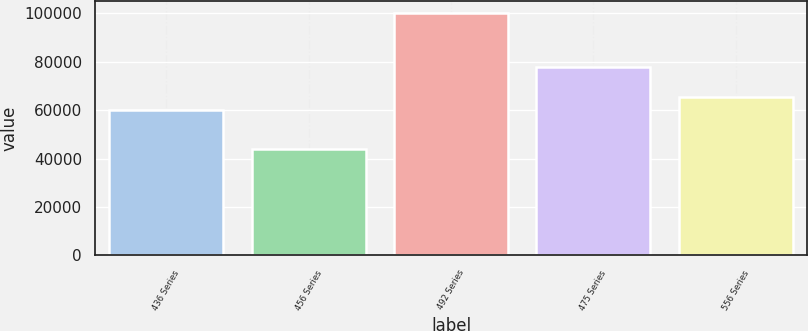Convert chart. <chart><loc_0><loc_0><loc_500><loc_500><bar_chart><fcel>436 Series<fcel>456 Series<fcel>492 Series<fcel>475 Series<fcel>556 Series<nl><fcel>59920<fcel>43887<fcel>100000<fcel>77798<fcel>65531.3<nl></chart> 